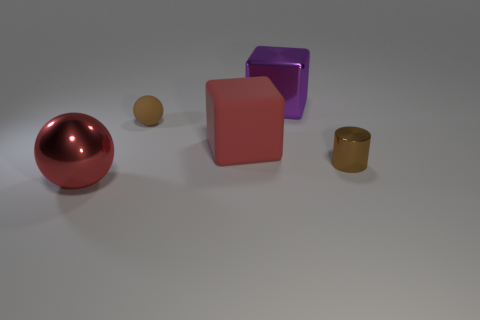Add 5 big metallic cubes. How many objects exist? 10 Subtract all balls. How many objects are left? 3 Add 5 red metal objects. How many red metal objects are left? 6 Add 5 matte balls. How many matte balls exist? 6 Subtract 0 red cylinders. How many objects are left? 5 Subtract all tiny brown rubber spheres. Subtract all rubber objects. How many objects are left? 2 